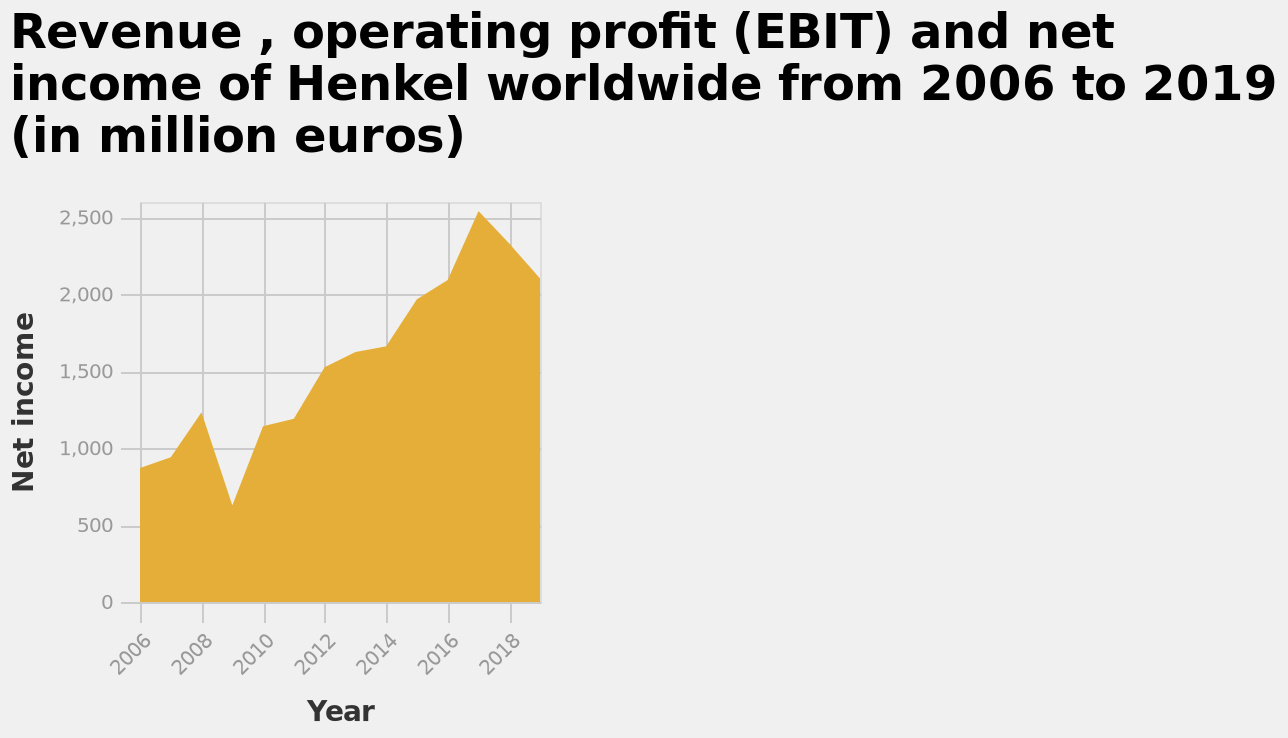<image>
Did net profits start to rise again after 2009? Yes, net profits started to rise again after the slight decline in 2009. please enumerates aspects of the construction of the chart Revenue , operating profit (EBIT) and net income of Henkel worldwide from 2006 to 2019 (in million euros) is a area diagram. Along the y-axis, Net income is measured. Along the x-axis, Year is defined. Was there an initial increase in net profit between 2006 to 2008?  Yes, there had been an increase in net profit between 2006 to 2008. 